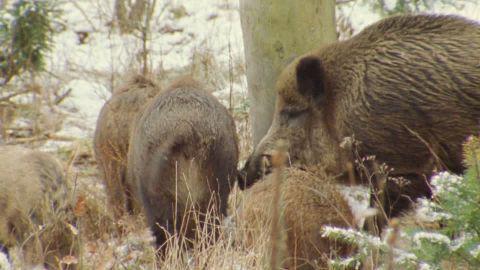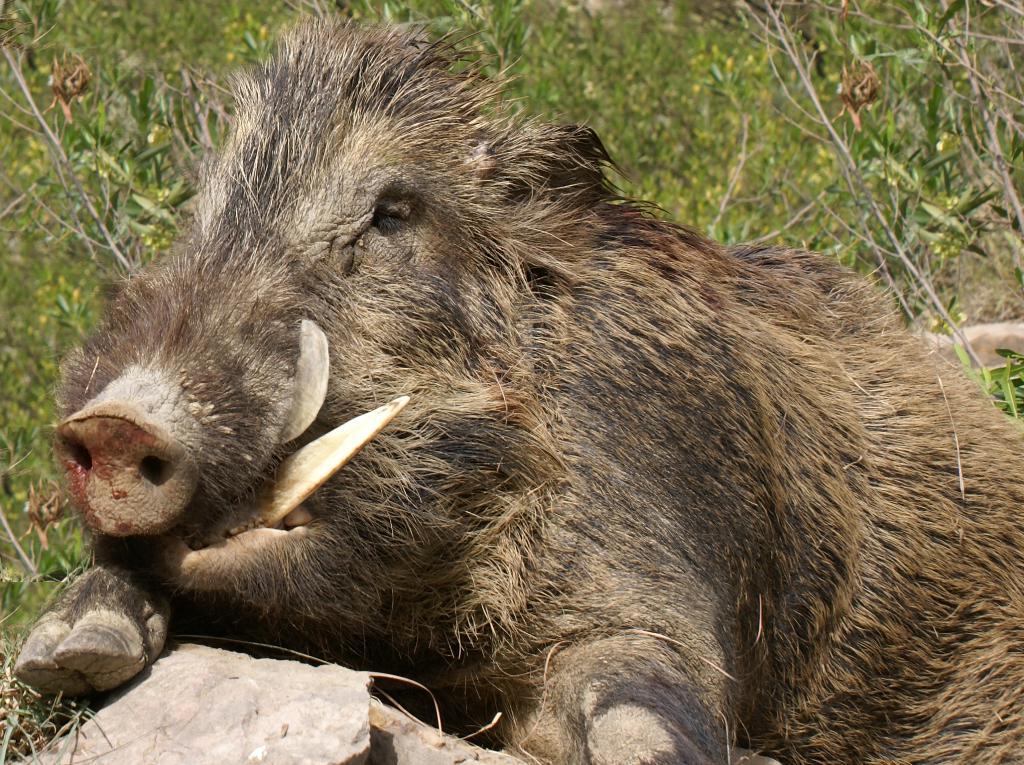The first image is the image on the left, the second image is the image on the right. Examine the images to the left and right. Is the description "there is one hog on the right image standing" accurate? Answer yes or no. No. 